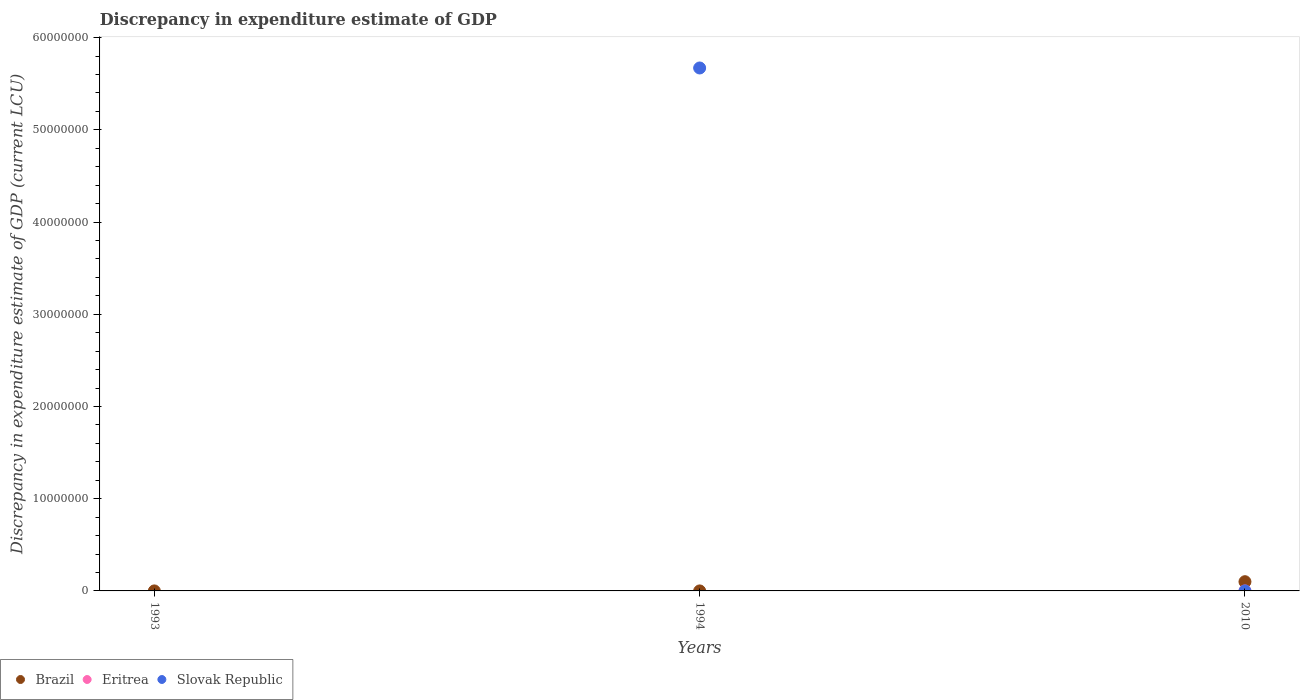What is the discrepancy in expenditure estimate of GDP in Brazil in 1994?
Provide a succinct answer. 0. Across all years, what is the maximum discrepancy in expenditure estimate of GDP in Eritrea?
Keep it short and to the point. 0. What is the total discrepancy in expenditure estimate of GDP in Eritrea in the graph?
Your response must be concise. 0. What is the difference between the discrepancy in expenditure estimate of GDP in Brazil in 1993 and that in 2010?
Offer a terse response. -1.00e+06. What is the difference between the discrepancy in expenditure estimate of GDP in Brazil in 1993 and the discrepancy in expenditure estimate of GDP in Eritrea in 1994?
Make the answer very short. 300. What is the average discrepancy in expenditure estimate of GDP in Eritrea per year?
Offer a terse response. 0. In the year 2010, what is the difference between the discrepancy in expenditure estimate of GDP in Slovak Republic and discrepancy in expenditure estimate of GDP in Eritrea?
Provide a short and direct response. -0. What is the ratio of the discrepancy in expenditure estimate of GDP in Brazil in 1993 to that in 2010?
Your answer should be very brief. 0. What is the difference between the highest and the lowest discrepancy in expenditure estimate of GDP in Slovak Republic?
Your answer should be compact. 5.67e+07. Is the sum of the discrepancy in expenditure estimate of GDP in Brazil in 1993 and 2010 greater than the maximum discrepancy in expenditure estimate of GDP in Eritrea across all years?
Provide a short and direct response. Yes. Is it the case that in every year, the sum of the discrepancy in expenditure estimate of GDP in Slovak Republic and discrepancy in expenditure estimate of GDP in Brazil  is greater than the discrepancy in expenditure estimate of GDP in Eritrea?
Your response must be concise. Yes. Does the discrepancy in expenditure estimate of GDP in Slovak Republic monotonically increase over the years?
Make the answer very short. No. How many dotlines are there?
Your response must be concise. 3. What is the difference between two consecutive major ticks on the Y-axis?
Your response must be concise. 1.00e+07. Does the graph contain any zero values?
Offer a very short reply. Yes. How many legend labels are there?
Offer a terse response. 3. What is the title of the graph?
Your response must be concise. Discrepancy in expenditure estimate of GDP. Does "Singapore" appear as one of the legend labels in the graph?
Give a very brief answer. No. What is the label or title of the Y-axis?
Keep it short and to the point. Discrepancy in expenditure estimate of GDP (current LCU). What is the Discrepancy in expenditure estimate of GDP (current LCU) of Brazil in 1993?
Offer a very short reply. 300. What is the Discrepancy in expenditure estimate of GDP (current LCU) in Eritrea in 1993?
Your answer should be compact. 0. What is the Discrepancy in expenditure estimate of GDP (current LCU) of Eritrea in 1994?
Your answer should be compact. 0. What is the Discrepancy in expenditure estimate of GDP (current LCU) of Slovak Republic in 1994?
Your response must be concise. 5.67e+07. What is the Discrepancy in expenditure estimate of GDP (current LCU) of Brazil in 2010?
Your response must be concise. 1.00e+06. What is the Discrepancy in expenditure estimate of GDP (current LCU) in Eritrea in 2010?
Provide a short and direct response. 0. What is the Discrepancy in expenditure estimate of GDP (current LCU) of Slovak Republic in 2010?
Your answer should be very brief. 7.62939453125e-6. Across all years, what is the maximum Discrepancy in expenditure estimate of GDP (current LCU) of Brazil?
Make the answer very short. 1.00e+06. Across all years, what is the maximum Discrepancy in expenditure estimate of GDP (current LCU) of Eritrea?
Provide a succinct answer. 0. Across all years, what is the maximum Discrepancy in expenditure estimate of GDP (current LCU) of Slovak Republic?
Keep it short and to the point. 5.67e+07. Across all years, what is the minimum Discrepancy in expenditure estimate of GDP (current LCU) of Brazil?
Make the answer very short. 0. What is the total Discrepancy in expenditure estimate of GDP (current LCU) of Brazil in the graph?
Your answer should be very brief. 1.00e+06. What is the total Discrepancy in expenditure estimate of GDP (current LCU) of Slovak Republic in the graph?
Ensure brevity in your answer.  5.67e+07. What is the difference between the Discrepancy in expenditure estimate of GDP (current LCU) of Brazil in 1993 and that in 2010?
Your answer should be compact. -1.00e+06. What is the difference between the Discrepancy in expenditure estimate of GDP (current LCU) in Slovak Republic in 1994 and that in 2010?
Keep it short and to the point. 5.67e+07. What is the difference between the Discrepancy in expenditure estimate of GDP (current LCU) of Brazil in 1993 and the Discrepancy in expenditure estimate of GDP (current LCU) of Slovak Republic in 1994?
Give a very brief answer. -5.67e+07. What is the difference between the Discrepancy in expenditure estimate of GDP (current LCU) of Brazil in 1993 and the Discrepancy in expenditure estimate of GDP (current LCU) of Eritrea in 2010?
Provide a succinct answer. 300. What is the difference between the Discrepancy in expenditure estimate of GDP (current LCU) in Brazil in 1993 and the Discrepancy in expenditure estimate of GDP (current LCU) in Slovak Republic in 2010?
Your answer should be compact. 300. What is the average Discrepancy in expenditure estimate of GDP (current LCU) of Brazil per year?
Your response must be concise. 3.33e+05. What is the average Discrepancy in expenditure estimate of GDP (current LCU) of Slovak Republic per year?
Your response must be concise. 1.89e+07. In the year 2010, what is the difference between the Discrepancy in expenditure estimate of GDP (current LCU) in Brazil and Discrepancy in expenditure estimate of GDP (current LCU) in Eritrea?
Your response must be concise. 1.00e+06. In the year 2010, what is the difference between the Discrepancy in expenditure estimate of GDP (current LCU) of Brazil and Discrepancy in expenditure estimate of GDP (current LCU) of Slovak Republic?
Keep it short and to the point. 1.00e+06. What is the ratio of the Discrepancy in expenditure estimate of GDP (current LCU) in Slovak Republic in 1994 to that in 2010?
Provide a short and direct response. 7.43e+12. What is the difference between the highest and the lowest Discrepancy in expenditure estimate of GDP (current LCU) in Brazil?
Provide a succinct answer. 1.00e+06. What is the difference between the highest and the lowest Discrepancy in expenditure estimate of GDP (current LCU) of Slovak Republic?
Provide a short and direct response. 5.67e+07. 